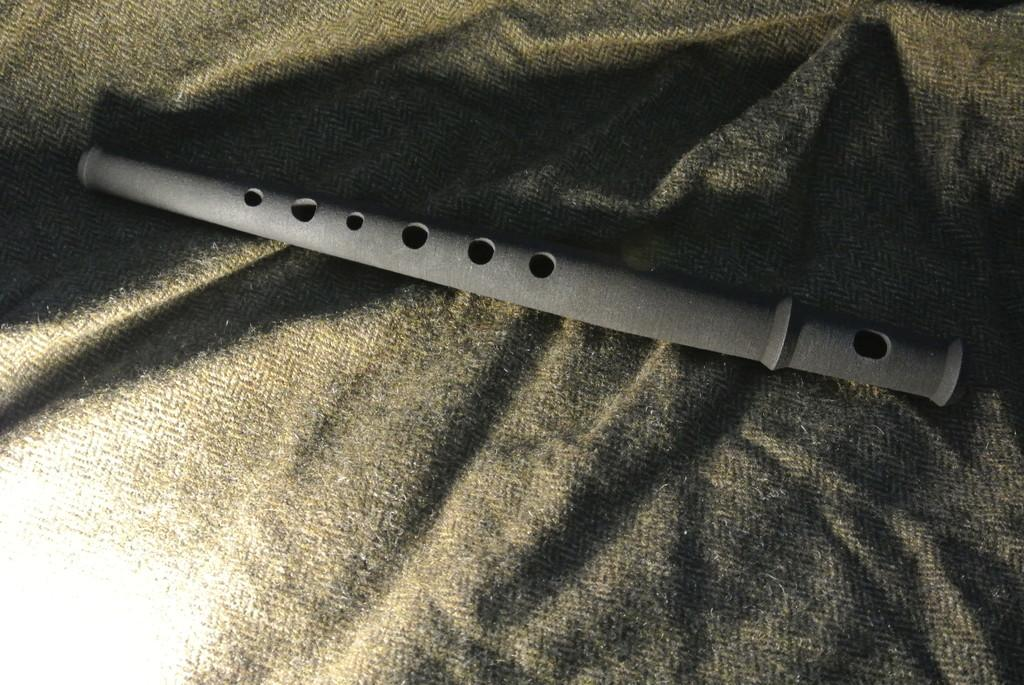What musical instrument is present in the image? There is a flute in the image. What is the flute placed on? The flute is on a cloth. What type of creature is playing the flute in the image? There is no creature present in the image, and the flute is not being played. 